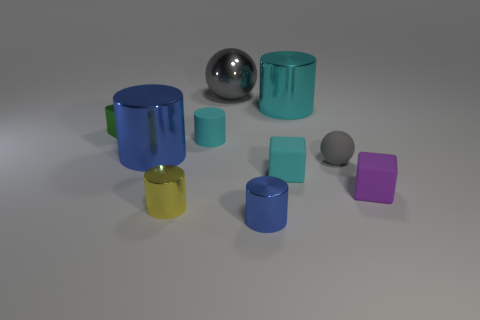Subtract all green blocks. How many blocks are left? 2 Subtract all big cyan metal cylinders. How many cylinders are left? 4 Subtract all cubes. How many objects are left? 7 Subtract 4 cylinders. How many cylinders are left? 1 Subtract all gray blocks. Subtract all brown spheres. How many blocks are left? 3 Subtract all yellow cylinders. How many cyan cubes are left? 1 Subtract all large yellow metallic things. Subtract all large gray shiny spheres. How many objects are left? 9 Add 1 gray rubber balls. How many gray rubber balls are left? 2 Add 9 tiny blue metallic objects. How many tiny blue metallic objects exist? 10 Subtract 0 blue blocks. How many objects are left? 10 